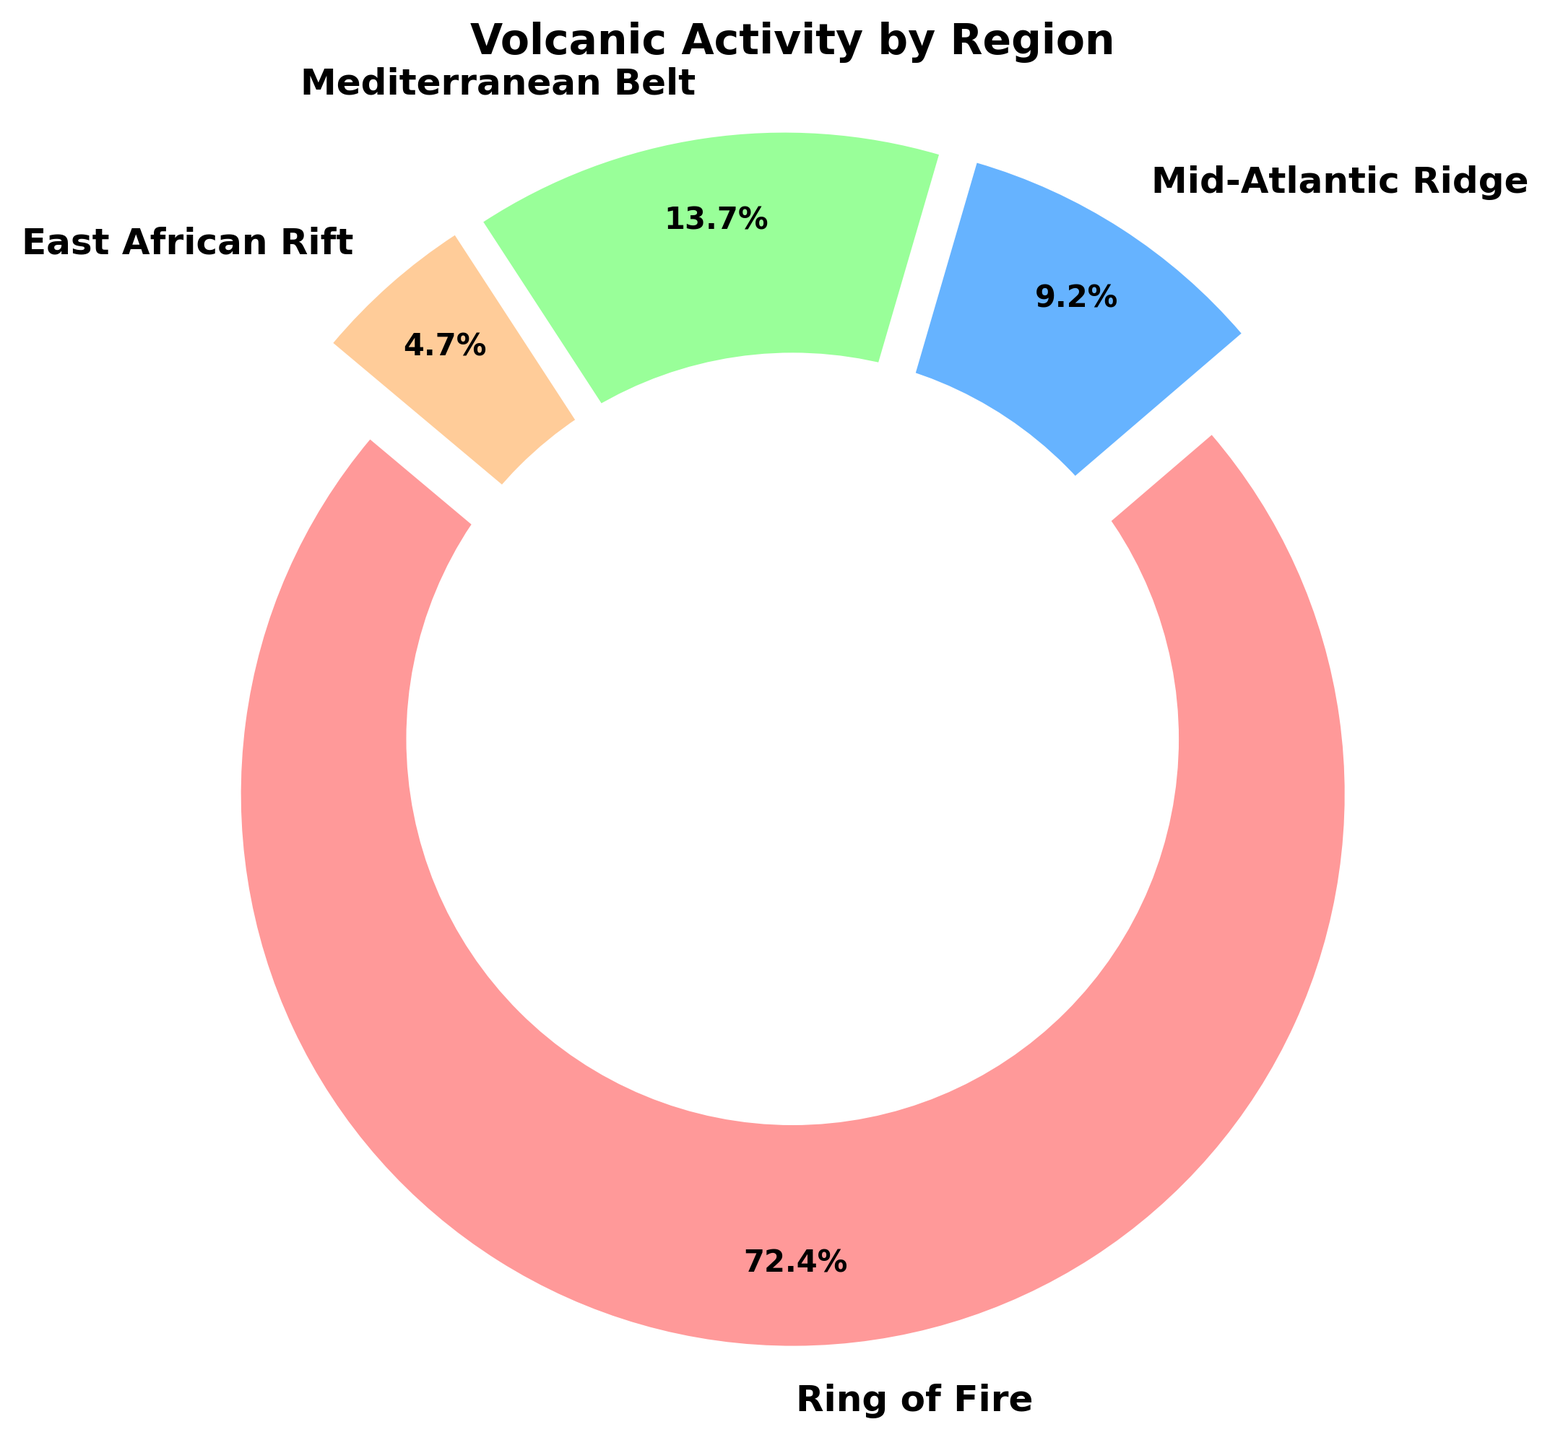Which region has the highest percentage of volcanic eruptions? The Ring of Fire slice is the largest, and the percentage shown on it is 70.1%.
Answer: Ring of Fire Which region has the smallest percentage of volcanic eruptions? The East African Rift slice is the smallest, and the percentage shown on it is 4.6%.
Answer: East African Rift How much larger is the volcanic activity in the Ring of Fire compared to the Mid-Atlantic Ridge in percentage terms? The Ring of Fire accounts for 70.1% while the Mid-Atlantic Ridge accounts for 8.9%. The difference is 70.1% - 8.9% = 61.2%.
Answer: 61.2% What's the total percentage of volcanic eruptions occurring outside the Ring of Fire? Sum the percentages of Mid-Atlantic Ridge (8.9%), Mediterranean Belt (13.3%), and East African Rift (4.6%). The total percentage is 8.9% + 13.3% + 4.6% = 26.8%.
Answer: 26.8% Which two regions together make up more than 20% but less than 30% of the total volcanic eruptions? Adding the percentages for each possible pair: Mid-Atlantic Ridge (8.9%) + Mediterranean Belt (13.3%) = 22.2%, Mid-Atlantic Ridge (8.9%) + East African Rift (4.6%) = 13.5%, and Mediterranean Belt (13.3%) + East African Rift (4.6%) = 17.9%. Only Mid-Atlantic Ridge and Mediterranean Belt together make more than 20% and less than 30%.
Answer: Mid-Atlantic Ridge and Mediterranean Belt What proportion of total volcanic eruptions does the Mediterranean Belt represent in decimal form? The Mediterranean Belt accounts for 13.3% of the total. As a decimal, this is 13.3 / 100 = 0.133.
Answer: 0.133 If the total number of volcanic eruptions is 489, how many eruptions have occurred in the East African Rift? The percentage of eruptions in the East African Rift is 4.6%. Thus, the number of eruptions is 4.6% of 489, calculated as (4.6/100) * 489 ≈ 22.494, which rounds to 23 eruptions.
Answer: 23 Compare the volcanic activity in the Ring of Fire to that in the Mediterranean Belt in terms of the times more frequent one is than the other. The Ring of Fire accounts for 70.1%, and the Mediterranean Belt for 13.3%. The Ring of Fire is more frequent by a factor of 70.1 / 13.3 ≈ 5.27.
Answer: 5.27 times 